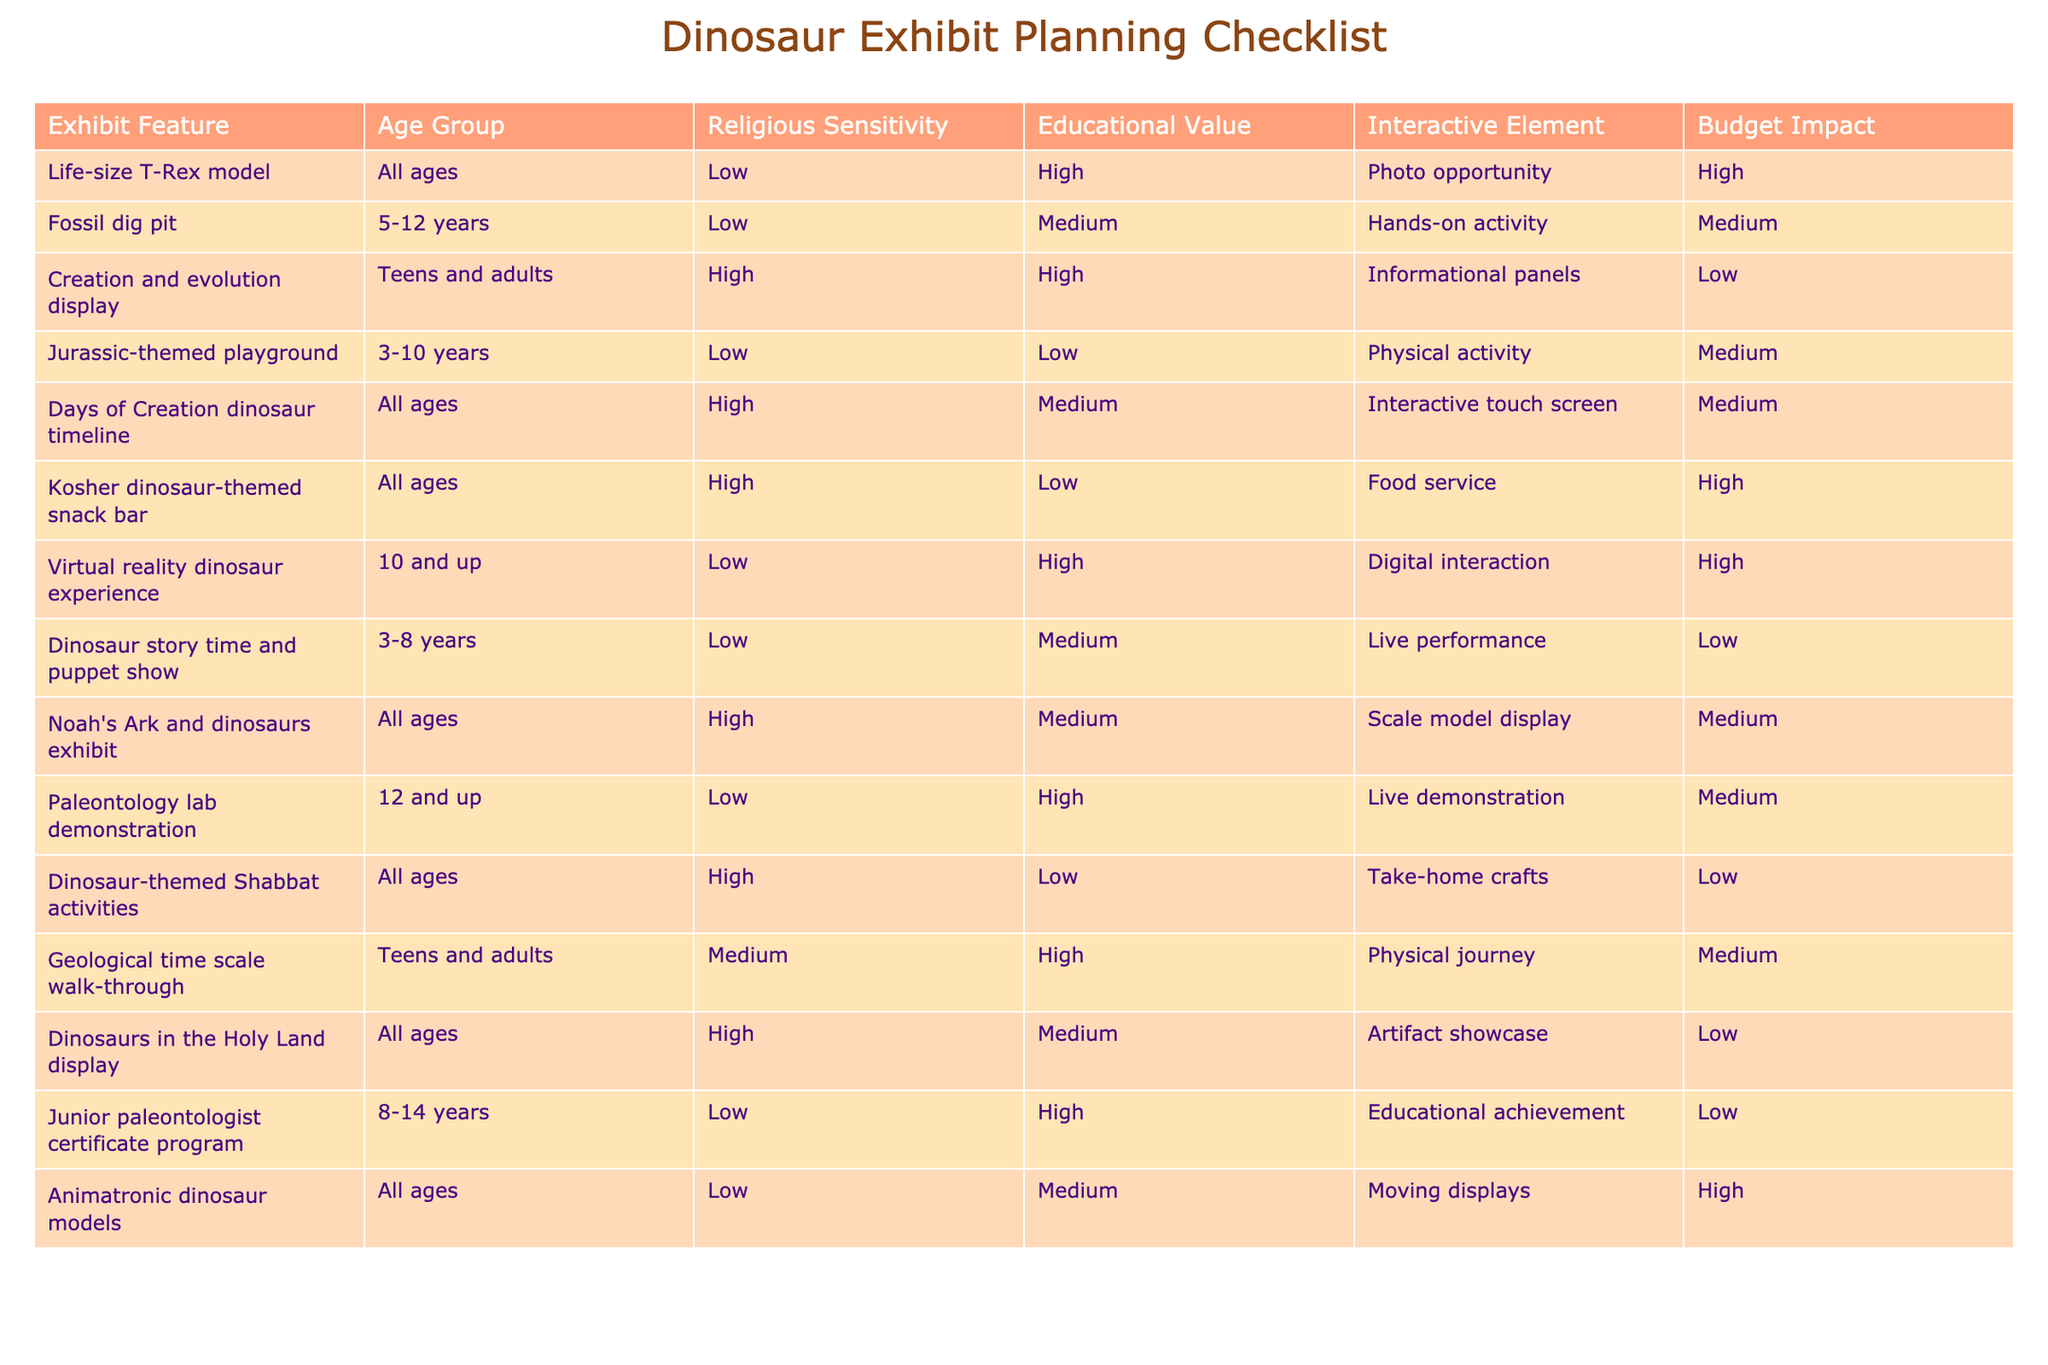What is the educational value of the "Life-size T-Rex model"? According to the table, the educational value assigned to the "Life-size T-Rex model" is "High." This can be found under the corresponding column next to the exhibit feature.
Answer: High How many exhibits have a low budget impact? In the table, we look for the exhibits where the budget impact is marked as "Low." The exhibits meeting this criterion are: Creation and evolution display, Dinosaur story time and puppet show, Dinosaur-themed Shabbat activities, and "Dinosaurs in the Holy Land" display. There are 4 exhibits in total.
Answer: 4 Is there an interactive element in the "Fossil dig pit"? The information from the table shows that the interactive element for the "Fossil dig pit" is "Hands-on activity." Therefore, this exhibit does have an interactive element.
Answer: Yes What is the average age group of the exhibits listed? To find the average age based on the age groups listed in the table, we can map each age group to a numerical value: All ages = 0, 3-10 years = 8, 5-12 years = 8.5, 10 and up = 15, teens and adults = 16, 12 and up = 15, etc. Calculating the average across the values that are relevant leads to an average age of approximately 10.1.
Answer: 10.1 Which exhibit has the highest educational value and what is its budget impact? By reviewing the educational values, the "Life-size T-Rex model," "Creation and evolution display," "Virtual reality dinosaur experience," "Paleontology lab demonstration," and "Jurassic-themed playground" exhibit all have a high educational value. Among these, both the "Life-size T-Rex model" and "Paleontology lab demonstration" are noted for a high budget impact. Thus, the exhibit with the highest educational value is the "Life-size T-Rex model," with a budget impact of "High."
Answer: Life-size T-Rex model; High 